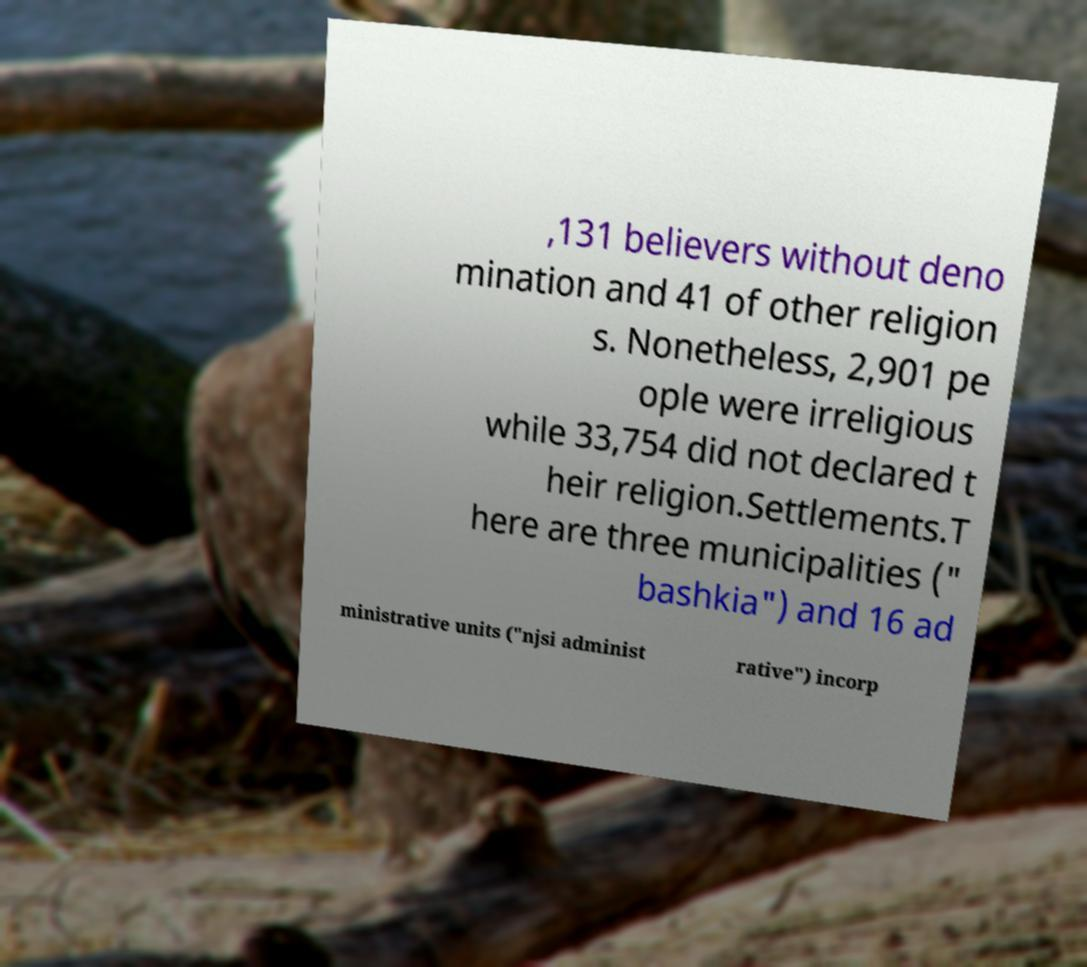Can you accurately transcribe the text from the provided image for me? ,131 believers without deno mination and 41 of other religion s. Nonetheless, 2,901 pe ople were irreligious while 33,754 did not declared t heir religion.Settlements.T here are three municipalities (" bashkia") and 16 ad ministrative units ("njsi administ rative") incorp 